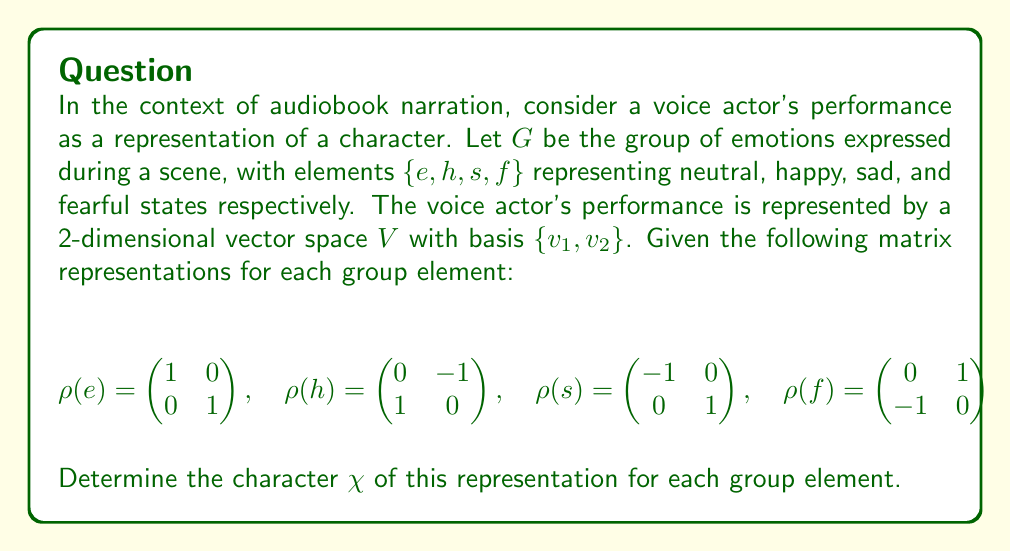Can you answer this question? To determine the character of a representation, we need to calculate the trace of each matrix representation. The trace of a matrix is the sum of its diagonal elements.

Step 1: Calculate $\chi(e)$
$$\chi(e) = \text{tr}(\rho(e)) = 1 + 1 = 2$$

Step 2: Calculate $\chi(h)$
$$\chi(h) = \text{tr}(\rho(h)) = 0 + 0 = 0$$

Step 3: Calculate $\chi(s)$
$$\chi(s) = \text{tr}(\rho(s)) = -1 + 1 = 0$$

Step 4: Calculate $\chi(f)$
$$\chi(f) = \text{tr}(\rho(f)) = 0 + 0 = 0$$

Therefore, the character of the representation for each group element is:
$\chi(e) = 2$, $\chi(h) = 0$, $\chi(s) = 0$, and $\chi(f) = 0$.

This character table provides insight into how the voice actor's performance changes for different emotional states in the audiobook narration.
Answer: $\chi(e) = 2$, $\chi(h) = \chi(s) = \chi(f) = 0$ 